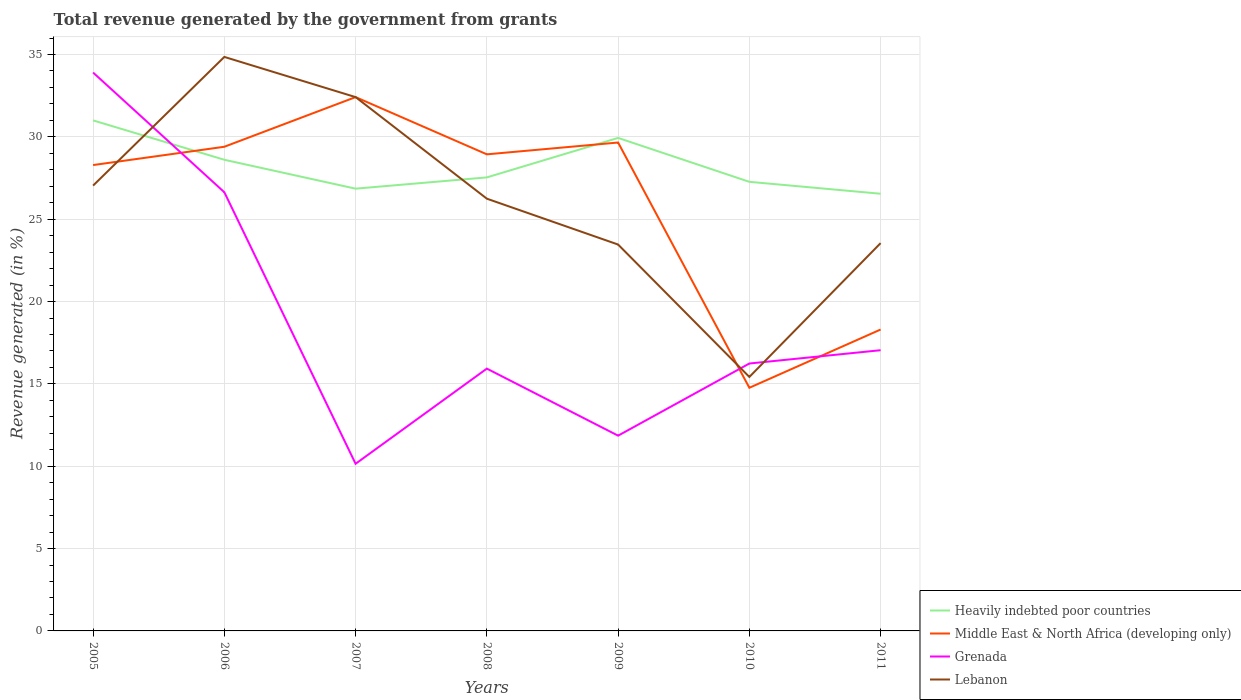How many different coloured lines are there?
Give a very brief answer. 4. Does the line corresponding to Heavily indebted poor countries intersect with the line corresponding to Grenada?
Provide a succinct answer. Yes. Is the number of lines equal to the number of legend labels?
Provide a succinct answer. Yes. Across all years, what is the maximum total revenue generated in Lebanon?
Your answer should be compact. 15.42. What is the total total revenue generated in Lebanon in the graph?
Offer a terse response. 2.7. What is the difference between the highest and the second highest total revenue generated in Lebanon?
Provide a short and direct response. 19.43. What is the difference between the highest and the lowest total revenue generated in Grenada?
Provide a short and direct response. 2. Is the total revenue generated in Grenada strictly greater than the total revenue generated in Middle East & North Africa (developing only) over the years?
Make the answer very short. No. How many lines are there?
Ensure brevity in your answer.  4. How many years are there in the graph?
Your answer should be compact. 7. What is the title of the graph?
Your response must be concise. Total revenue generated by the government from grants. Does "Solomon Islands" appear as one of the legend labels in the graph?
Your answer should be very brief. No. What is the label or title of the X-axis?
Make the answer very short. Years. What is the label or title of the Y-axis?
Provide a short and direct response. Revenue generated (in %). What is the Revenue generated (in %) of Heavily indebted poor countries in 2005?
Your answer should be compact. 31. What is the Revenue generated (in %) of Middle East & North Africa (developing only) in 2005?
Provide a short and direct response. 28.29. What is the Revenue generated (in %) of Grenada in 2005?
Your answer should be very brief. 33.9. What is the Revenue generated (in %) of Lebanon in 2005?
Your answer should be compact. 27.04. What is the Revenue generated (in %) of Heavily indebted poor countries in 2006?
Your answer should be very brief. 28.61. What is the Revenue generated (in %) of Middle East & North Africa (developing only) in 2006?
Make the answer very short. 29.4. What is the Revenue generated (in %) in Grenada in 2006?
Provide a succinct answer. 26.64. What is the Revenue generated (in %) in Lebanon in 2006?
Offer a very short reply. 34.85. What is the Revenue generated (in %) of Heavily indebted poor countries in 2007?
Your answer should be very brief. 26.85. What is the Revenue generated (in %) of Middle East & North Africa (developing only) in 2007?
Give a very brief answer. 32.41. What is the Revenue generated (in %) in Grenada in 2007?
Provide a succinct answer. 10.15. What is the Revenue generated (in %) of Lebanon in 2007?
Provide a short and direct response. 32.41. What is the Revenue generated (in %) in Heavily indebted poor countries in 2008?
Your response must be concise. 27.54. What is the Revenue generated (in %) in Middle East & North Africa (developing only) in 2008?
Give a very brief answer. 28.94. What is the Revenue generated (in %) of Grenada in 2008?
Provide a succinct answer. 15.93. What is the Revenue generated (in %) of Lebanon in 2008?
Offer a very short reply. 26.24. What is the Revenue generated (in %) of Heavily indebted poor countries in 2009?
Offer a terse response. 29.93. What is the Revenue generated (in %) in Middle East & North Africa (developing only) in 2009?
Ensure brevity in your answer.  29.65. What is the Revenue generated (in %) in Grenada in 2009?
Ensure brevity in your answer.  11.86. What is the Revenue generated (in %) in Lebanon in 2009?
Offer a terse response. 23.46. What is the Revenue generated (in %) of Heavily indebted poor countries in 2010?
Ensure brevity in your answer.  27.27. What is the Revenue generated (in %) in Middle East & North Africa (developing only) in 2010?
Provide a succinct answer. 14.76. What is the Revenue generated (in %) in Grenada in 2010?
Your answer should be very brief. 16.24. What is the Revenue generated (in %) of Lebanon in 2010?
Offer a very short reply. 15.42. What is the Revenue generated (in %) of Heavily indebted poor countries in 2011?
Your answer should be compact. 26.54. What is the Revenue generated (in %) in Middle East & North Africa (developing only) in 2011?
Give a very brief answer. 18.3. What is the Revenue generated (in %) of Grenada in 2011?
Give a very brief answer. 17.04. What is the Revenue generated (in %) of Lebanon in 2011?
Keep it short and to the point. 23.55. Across all years, what is the maximum Revenue generated (in %) of Heavily indebted poor countries?
Offer a terse response. 31. Across all years, what is the maximum Revenue generated (in %) of Middle East & North Africa (developing only)?
Your response must be concise. 32.41. Across all years, what is the maximum Revenue generated (in %) of Grenada?
Provide a short and direct response. 33.9. Across all years, what is the maximum Revenue generated (in %) in Lebanon?
Provide a short and direct response. 34.85. Across all years, what is the minimum Revenue generated (in %) in Heavily indebted poor countries?
Offer a terse response. 26.54. Across all years, what is the minimum Revenue generated (in %) of Middle East & North Africa (developing only)?
Provide a succinct answer. 14.76. Across all years, what is the minimum Revenue generated (in %) in Grenada?
Offer a terse response. 10.15. Across all years, what is the minimum Revenue generated (in %) of Lebanon?
Offer a terse response. 15.42. What is the total Revenue generated (in %) of Heavily indebted poor countries in the graph?
Ensure brevity in your answer.  197.75. What is the total Revenue generated (in %) of Middle East & North Africa (developing only) in the graph?
Your response must be concise. 181.75. What is the total Revenue generated (in %) of Grenada in the graph?
Provide a short and direct response. 131.75. What is the total Revenue generated (in %) of Lebanon in the graph?
Your answer should be very brief. 182.98. What is the difference between the Revenue generated (in %) in Heavily indebted poor countries in 2005 and that in 2006?
Ensure brevity in your answer.  2.39. What is the difference between the Revenue generated (in %) of Middle East & North Africa (developing only) in 2005 and that in 2006?
Your response must be concise. -1.11. What is the difference between the Revenue generated (in %) of Grenada in 2005 and that in 2006?
Provide a succinct answer. 7.27. What is the difference between the Revenue generated (in %) of Lebanon in 2005 and that in 2006?
Your answer should be very brief. -7.81. What is the difference between the Revenue generated (in %) in Heavily indebted poor countries in 2005 and that in 2007?
Your response must be concise. 4.15. What is the difference between the Revenue generated (in %) of Middle East & North Africa (developing only) in 2005 and that in 2007?
Your response must be concise. -4.13. What is the difference between the Revenue generated (in %) in Grenada in 2005 and that in 2007?
Give a very brief answer. 23.75. What is the difference between the Revenue generated (in %) in Lebanon in 2005 and that in 2007?
Ensure brevity in your answer.  -5.37. What is the difference between the Revenue generated (in %) in Heavily indebted poor countries in 2005 and that in 2008?
Offer a very short reply. 3.46. What is the difference between the Revenue generated (in %) in Middle East & North Africa (developing only) in 2005 and that in 2008?
Your response must be concise. -0.65. What is the difference between the Revenue generated (in %) in Grenada in 2005 and that in 2008?
Keep it short and to the point. 17.98. What is the difference between the Revenue generated (in %) in Lebanon in 2005 and that in 2008?
Offer a very short reply. 0.79. What is the difference between the Revenue generated (in %) of Heavily indebted poor countries in 2005 and that in 2009?
Provide a succinct answer. 1.06. What is the difference between the Revenue generated (in %) of Middle East & North Africa (developing only) in 2005 and that in 2009?
Keep it short and to the point. -1.37. What is the difference between the Revenue generated (in %) of Grenada in 2005 and that in 2009?
Ensure brevity in your answer.  22.05. What is the difference between the Revenue generated (in %) in Lebanon in 2005 and that in 2009?
Your answer should be very brief. 3.58. What is the difference between the Revenue generated (in %) in Heavily indebted poor countries in 2005 and that in 2010?
Make the answer very short. 3.73. What is the difference between the Revenue generated (in %) in Middle East & North Africa (developing only) in 2005 and that in 2010?
Your answer should be very brief. 13.52. What is the difference between the Revenue generated (in %) in Grenada in 2005 and that in 2010?
Keep it short and to the point. 17.67. What is the difference between the Revenue generated (in %) in Lebanon in 2005 and that in 2010?
Provide a short and direct response. 11.62. What is the difference between the Revenue generated (in %) of Heavily indebted poor countries in 2005 and that in 2011?
Ensure brevity in your answer.  4.45. What is the difference between the Revenue generated (in %) in Middle East & North Africa (developing only) in 2005 and that in 2011?
Provide a succinct answer. 9.99. What is the difference between the Revenue generated (in %) in Grenada in 2005 and that in 2011?
Your answer should be compact. 16.86. What is the difference between the Revenue generated (in %) in Lebanon in 2005 and that in 2011?
Give a very brief answer. 3.49. What is the difference between the Revenue generated (in %) in Heavily indebted poor countries in 2006 and that in 2007?
Keep it short and to the point. 1.75. What is the difference between the Revenue generated (in %) of Middle East & North Africa (developing only) in 2006 and that in 2007?
Your answer should be very brief. -3.01. What is the difference between the Revenue generated (in %) of Grenada in 2006 and that in 2007?
Your answer should be very brief. 16.49. What is the difference between the Revenue generated (in %) in Lebanon in 2006 and that in 2007?
Ensure brevity in your answer.  2.44. What is the difference between the Revenue generated (in %) in Heavily indebted poor countries in 2006 and that in 2008?
Offer a very short reply. 1.07. What is the difference between the Revenue generated (in %) of Middle East & North Africa (developing only) in 2006 and that in 2008?
Provide a succinct answer. 0.46. What is the difference between the Revenue generated (in %) in Grenada in 2006 and that in 2008?
Provide a succinct answer. 10.71. What is the difference between the Revenue generated (in %) of Lebanon in 2006 and that in 2008?
Your answer should be very brief. 8.61. What is the difference between the Revenue generated (in %) in Heavily indebted poor countries in 2006 and that in 2009?
Your answer should be very brief. -1.33. What is the difference between the Revenue generated (in %) of Middle East & North Africa (developing only) in 2006 and that in 2009?
Make the answer very short. -0.26. What is the difference between the Revenue generated (in %) of Grenada in 2006 and that in 2009?
Provide a succinct answer. 14.78. What is the difference between the Revenue generated (in %) in Lebanon in 2006 and that in 2009?
Your answer should be compact. 11.39. What is the difference between the Revenue generated (in %) in Heavily indebted poor countries in 2006 and that in 2010?
Offer a terse response. 1.34. What is the difference between the Revenue generated (in %) in Middle East & North Africa (developing only) in 2006 and that in 2010?
Your response must be concise. 14.63. What is the difference between the Revenue generated (in %) in Grenada in 2006 and that in 2010?
Your answer should be compact. 10.4. What is the difference between the Revenue generated (in %) of Lebanon in 2006 and that in 2010?
Offer a terse response. 19.43. What is the difference between the Revenue generated (in %) of Heavily indebted poor countries in 2006 and that in 2011?
Ensure brevity in your answer.  2.06. What is the difference between the Revenue generated (in %) in Middle East & North Africa (developing only) in 2006 and that in 2011?
Give a very brief answer. 11.1. What is the difference between the Revenue generated (in %) in Grenada in 2006 and that in 2011?
Your answer should be very brief. 9.59. What is the difference between the Revenue generated (in %) of Lebanon in 2006 and that in 2011?
Offer a terse response. 11.31. What is the difference between the Revenue generated (in %) in Heavily indebted poor countries in 2007 and that in 2008?
Offer a terse response. -0.68. What is the difference between the Revenue generated (in %) of Middle East & North Africa (developing only) in 2007 and that in 2008?
Provide a short and direct response. 3.47. What is the difference between the Revenue generated (in %) in Grenada in 2007 and that in 2008?
Ensure brevity in your answer.  -5.78. What is the difference between the Revenue generated (in %) of Lebanon in 2007 and that in 2008?
Provide a short and direct response. 6.17. What is the difference between the Revenue generated (in %) of Heavily indebted poor countries in 2007 and that in 2009?
Provide a succinct answer. -3.08. What is the difference between the Revenue generated (in %) of Middle East & North Africa (developing only) in 2007 and that in 2009?
Make the answer very short. 2.76. What is the difference between the Revenue generated (in %) in Grenada in 2007 and that in 2009?
Ensure brevity in your answer.  -1.71. What is the difference between the Revenue generated (in %) in Lebanon in 2007 and that in 2009?
Give a very brief answer. 8.95. What is the difference between the Revenue generated (in %) in Heavily indebted poor countries in 2007 and that in 2010?
Give a very brief answer. -0.42. What is the difference between the Revenue generated (in %) of Middle East & North Africa (developing only) in 2007 and that in 2010?
Provide a succinct answer. 17.65. What is the difference between the Revenue generated (in %) in Grenada in 2007 and that in 2010?
Make the answer very short. -6.09. What is the difference between the Revenue generated (in %) in Lebanon in 2007 and that in 2010?
Your answer should be compact. 16.99. What is the difference between the Revenue generated (in %) of Heavily indebted poor countries in 2007 and that in 2011?
Keep it short and to the point. 0.31. What is the difference between the Revenue generated (in %) of Middle East & North Africa (developing only) in 2007 and that in 2011?
Offer a terse response. 14.11. What is the difference between the Revenue generated (in %) of Grenada in 2007 and that in 2011?
Give a very brief answer. -6.89. What is the difference between the Revenue generated (in %) in Lebanon in 2007 and that in 2011?
Provide a succinct answer. 8.87. What is the difference between the Revenue generated (in %) of Heavily indebted poor countries in 2008 and that in 2009?
Keep it short and to the point. -2.4. What is the difference between the Revenue generated (in %) of Middle East & North Africa (developing only) in 2008 and that in 2009?
Make the answer very short. -0.72. What is the difference between the Revenue generated (in %) of Grenada in 2008 and that in 2009?
Your answer should be compact. 4.07. What is the difference between the Revenue generated (in %) in Lebanon in 2008 and that in 2009?
Keep it short and to the point. 2.78. What is the difference between the Revenue generated (in %) in Heavily indebted poor countries in 2008 and that in 2010?
Provide a succinct answer. 0.27. What is the difference between the Revenue generated (in %) in Middle East & North Africa (developing only) in 2008 and that in 2010?
Offer a terse response. 14.17. What is the difference between the Revenue generated (in %) in Grenada in 2008 and that in 2010?
Provide a succinct answer. -0.31. What is the difference between the Revenue generated (in %) of Lebanon in 2008 and that in 2010?
Provide a short and direct response. 10.82. What is the difference between the Revenue generated (in %) in Heavily indebted poor countries in 2008 and that in 2011?
Make the answer very short. 0.99. What is the difference between the Revenue generated (in %) of Middle East & North Africa (developing only) in 2008 and that in 2011?
Your answer should be compact. 10.64. What is the difference between the Revenue generated (in %) of Grenada in 2008 and that in 2011?
Offer a very short reply. -1.12. What is the difference between the Revenue generated (in %) of Lebanon in 2008 and that in 2011?
Your answer should be very brief. 2.7. What is the difference between the Revenue generated (in %) in Heavily indebted poor countries in 2009 and that in 2010?
Your answer should be compact. 2.67. What is the difference between the Revenue generated (in %) of Middle East & North Africa (developing only) in 2009 and that in 2010?
Offer a very short reply. 14.89. What is the difference between the Revenue generated (in %) of Grenada in 2009 and that in 2010?
Your response must be concise. -4.38. What is the difference between the Revenue generated (in %) in Lebanon in 2009 and that in 2010?
Offer a terse response. 8.04. What is the difference between the Revenue generated (in %) in Heavily indebted poor countries in 2009 and that in 2011?
Provide a short and direct response. 3.39. What is the difference between the Revenue generated (in %) of Middle East & North Africa (developing only) in 2009 and that in 2011?
Your answer should be compact. 11.35. What is the difference between the Revenue generated (in %) in Grenada in 2009 and that in 2011?
Keep it short and to the point. -5.19. What is the difference between the Revenue generated (in %) in Lebanon in 2009 and that in 2011?
Give a very brief answer. -0.09. What is the difference between the Revenue generated (in %) of Heavily indebted poor countries in 2010 and that in 2011?
Your response must be concise. 0.72. What is the difference between the Revenue generated (in %) of Middle East & North Africa (developing only) in 2010 and that in 2011?
Your response must be concise. -3.54. What is the difference between the Revenue generated (in %) in Grenada in 2010 and that in 2011?
Ensure brevity in your answer.  -0.81. What is the difference between the Revenue generated (in %) of Lebanon in 2010 and that in 2011?
Make the answer very short. -8.13. What is the difference between the Revenue generated (in %) of Heavily indebted poor countries in 2005 and the Revenue generated (in %) of Middle East & North Africa (developing only) in 2006?
Keep it short and to the point. 1.6. What is the difference between the Revenue generated (in %) in Heavily indebted poor countries in 2005 and the Revenue generated (in %) in Grenada in 2006?
Give a very brief answer. 4.36. What is the difference between the Revenue generated (in %) of Heavily indebted poor countries in 2005 and the Revenue generated (in %) of Lebanon in 2006?
Make the answer very short. -3.85. What is the difference between the Revenue generated (in %) of Middle East & North Africa (developing only) in 2005 and the Revenue generated (in %) of Grenada in 2006?
Provide a succinct answer. 1.65. What is the difference between the Revenue generated (in %) in Middle East & North Africa (developing only) in 2005 and the Revenue generated (in %) in Lebanon in 2006?
Provide a succinct answer. -6.57. What is the difference between the Revenue generated (in %) in Grenada in 2005 and the Revenue generated (in %) in Lebanon in 2006?
Offer a terse response. -0.95. What is the difference between the Revenue generated (in %) of Heavily indebted poor countries in 2005 and the Revenue generated (in %) of Middle East & North Africa (developing only) in 2007?
Provide a short and direct response. -1.41. What is the difference between the Revenue generated (in %) in Heavily indebted poor countries in 2005 and the Revenue generated (in %) in Grenada in 2007?
Provide a succinct answer. 20.85. What is the difference between the Revenue generated (in %) in Heavily indebted poor countries in 2005 and the Revenue generated (in %) in Lebanon in 2007?
Offer a terse response. -1.41. What is the difference between the Revenue generated (in %) of Middle East & North Africa (developing only) in 2005 and the Revenue generated (in %) of Grenada in 2007?
Offer a very short reply. 18.14. What is the difference between the Revenue generated (in %) of Middle East & North Africa (developing only) in 2005 and the Revenue generated (in %) of Lebanon in 2007?
Provide a succinct answer. -4.13. What is the difference between the Revenue generated (in %) of Grenada in 2005 and the Revenue generated (in %) of Lebanon in 2007?
Offer a very short reply. 1.49. What is the difference between the Revenue generated (in %) in Heavily indebted poor countries in 2005 and the Revenue generated (in %) in Middle East & North Africa (developing only) in 2008?
Offer a very short reply. 2.06. What is the difference between the Revenue generated (in %) of Heavily indebted poor countries in 2005 and the Revenue generated (in %) of Grenada in 2008?
Provide a succinct answer. 15.07. What is the difference between the Revenue generated (in %) in Heavily indebted poor countries in 2005 and the Revenue generated (in %) in Lebanon in 2008?
Your answer should be compact. 4.75. What is the difference between the Revenue generated (in %) of Middle East & North Africa (developing only) in 2005 and the Revenue generated (in %) of Grenada in 2008?
Your response must be concise. 12.36. What is the difference between the Revenue generated (in %) of Middle East & North Africa (developing only) in 2005 and the Revenue generated (in %) of Lebanon in 2008?
Your answer should be compact. 2.04. What is the difference between the Revenue generated (in %) of Grenada in 2005 and the Revenue generated (in %) of Lebanon in 2008?
Make the answer very short. 7.66. What is the difference between the Revenue generated (in %) in Heavily indebted poor countries in 2005 and the Revenue generated (in %) in Middle East & North Africa (developing only) in 2009?
Your answer should be very brief. 1.34. What is the difference between the Revenue generated (in %) in Heavily indebted poor countries in 2005 and the Revenue generated (in %) in Grenada in 2009?
Provide a short and direct response. 19.14. What is the difference between the Revenue generated (in %) in Heavily indebted poor countries in 2005 and the Revenue generated (in %) in Lebanon in 2009?
Provide a short and direct response. 7.54. What is the difference between the Revenue generated (in %) of Middle East & North Africa (developing only) in 2005 and the Revenue generated (in %) of Grenada in 2009?
Offer a terse response. 16.43. What is the difference between the Revenue generated (in %) in Middle East & North Africa (developing only) in 2005 and the Revenue generated (in %) in Lebanon in 2009?
Your answer should be very brief. 4.83. What is the difference between the Revenue generated (in %) of Grenada in 2005 and the Revenue generated (in %) of Lebanon in 2009?
Offer a terse response. 10.44. What is the difference between the Revenue generated (in %) in Heavily indebted poor countries in 2005 and the Revenue generated (in %) in Middle East & North Africa (developing only) in 2010?
Your answer should be compact. 16.23. What is the difference between the Revenue generated (in %) in Heavily indebted poor countries in 2005 and the Revenue generated (in %) in Grenada in 2010?
Provide a succinct answer. 14.76. What is the difference between the Revenue generated (in %) of Heavily indebted poor countries in 2005 and the Revenue generated (in %) of Lebanon in 2010?
Your response must be concise. 15.58. What is the difference between the Revenue generated (in %) in Middle East & North Africa (developing only) in 2005 and the Revenue generated (in %) in Grenada in 2010?
Provide a short and direct response. 12.05. What is the difference between the Revenue generated (in %) in Middle East & North Africa (developing only) in 2005 and the Revenue generated (in %) in Lebanon in 2010?
Ensure brevity in your answer.  12.87. What is the difference between the Revenue generated (in %) of Grenada in 2005 and the Revenue generated (in %) of Lebanon in 2010?
Make the answer very short. 18.48. What is the difference between the Revenue generated (in %) of Heavily indebted poor countries in 2005 and the Revenue generated (in %) of Middle East & North Africa (developing only) in 2011?
Offer a terse response. 12.7. What is the difference between the Revenue generated (in %) in Heavily indebted poor countries in 2005 and the Revenue generated (in %) in Grenada in 2011?
Give a very brief answer. 13.95. What is the difference between the Revenue generated (in %) of Heavily indebted poor countries in 2005 and the Revenue generated (in %) of Lebanon in 2011?
Ensure brevity in your answer.  7.45. What is the difference between the Revenue generated (in %) of Middle East & North Africa (developing only) in 2005 and the Revenue generated (in %) of Grenada in 2011?
Keep it short and to the point. 11.24. What is the difference between the Revenue generated (in %) of Middle East & North Africa (developing only) in 2005 and the Revenue generated (in %) of Lebanon in 2011?
Offer a very short reply. 4.74. What is the difference between the Revenue generated (in %) in Grenada in 2005 and the Revenue generated (in %) in Lebanon in 2011?
Your answer should be compact. 10.36. What is the difference between the Revenue generated (in %) in Heavily indebted poor countries in 2006 and the Revenue generated (in %) in Middle East & North Africa (developing only) in 2007?
Provide a succinct answer. -3.8. What is the difference between the Revenue generated (in %) in Heavily indebted poor countries in 2006 and the Revenue generated (in %) in Grenada in 2007?
Ensure brevity in your answer.  18.46. What is the difference between the Revenue generated (in %) of Heavily indebted poor countries in 2006 and the Revenue generated (in %) of Lebanon in 2007?
Give a very brief answer. -3.8. What is the difference between the Revenue generated (in %) of Middle East & North Africa (developing only) in 2006 and the Revenue generated (in %) of Grenada in 2007?
Your answer should be compact. 19.25. What is the difference between the Revenue generated (in %) of Middle East & North Africa (developing only) in 2006 and the Revenue generated (in %) of Lebanon in 2007?
Your response must be concise. -3.01. What is the difference between the Revenue generated (in %) in Grenada in 2006 and the Revenue generated (in %) in Lebanon in 2007?
Your answer should be compact. -5.78. What is the difference between the Revenue generated (in %) in Heavily indebted poor countries in 2006 and the Revenue generated (in %) in Middle East & North Africa (developing only) in 2008?
Ensure brevity in your answer.  -0.33. What is the difference between the Revenue generated (in %) in Heavily indebted poor countries in 2006 and the Revenue generated (in %) in Grenada in 2008?
Provide a succinct answer. 12.68. What is the difference between the Revenue generated (in %) in Heavily indebted poor countries in 2006 and the Revenue generated (in %) in Lebanon in 2008?
Make the answer very short. 2.36. What is the difference between the Revenue generated (in %) of Middle East & North Africa (developing only) in 2006 and the Revenue generated (in %) of Grenada in 2008?
Make the answer very short. 13.47. What is the difference between the Revenue generated (in %) of Middle East & North Africa (developing only) in 2006 and the Revenue generated (in %) of Lebanon in 2008?
Your answer should be compact. 3.15. What is the difference between the Revenue generated (in %) in Grenada in 2006 and the Revenue generated (in %) in Lebanon in 2008?
Your answer should be compact. 0.39. What is the difference between the Revenue generated (in %) of Heavily indebted poor countries in 2006 and the Revenue generated (in %) of Middle East & North Africa (developing only) in 2009?
Make the answer very short. -1.05. What is the difference between the Revenue generated (in %) of Heavily indebted poor countries in 2006 and the Revenue generated (in %) of Grenada in 2009?
Offer a very short reply. 16.75. What is the difference between the Revenue generated (in %) of Heavily indebted poor countries in 2006 and the Revenue generated (in %) of Lebanon in 2009?
Make the answer very short. 5.15. What is the difference between the Revenue generated (in %) in Middle East & North Africa (developing only) in 2006 and the Revenue generated (in %) in Grenada in 2009?
Give a very brief answer. 17.54. What is the difference between the Revenue generated (in %) of Middle East & North Africa (developing only) in 2006 and the Revenue generated (in %) of Lebanon in 2009?
Offer a terse response. 5.94. What is the difference between the Revenue generated (in %) in Grenada in 2006 and the Revenue generated (in %) in Lebanon in 2009?
Give a very brief answer. 3.17. What is the difference between the Revenue generated (in %) of Heavily indebted poor countries in 2006 and the Revenue generated (in %) of Middle East & North Africa (developing only) in 2010?
Make the answer very short. 13.84. What is the difference between the Revenue generated (in %) in Heavily indebted poor countries in 2006 and the Revenue generated (in %) in Grenada in 2010?
Keep it short and to the point. 12.37. What is the difference between the Revenue generated (in %) of Heavily indebted poor countries in 2006 and the Revenue generated (in %) of Lebanon in 2010?
Provide a succinct answer. 13.19. What is the difference between the Revenue generated (in %) in Middle East & North Africa (developing only) in 2006 and the Revenue generated (in %) in Grenada in 2010?
Keep it short and to the point. 13.16. What is the difference between the Revenue generated (in %) of Middle East & North Africa (developing only) in 2006 and the Revenue generated (in %) of Lebanon in 2010?
Ensure brevity in your answer.  13.98. What is the difference between the Revenue generated (in %) of Grenada in 2006 and the Revenue generated (in %) of Lebanon in 2010?
Provide a succinct answer. 11.21. What is the difference between the Revenue generated (in %) in Heavily indebted poor countries in 2006 and the Revenue generated (in %) in Middle East & North Africa (developing only) in 2011?
Your response must be concise. 10.31. What is the difference between the Revenue generated (in %) of Heavily indebted poor countries in 2006 and the Revenue generated (in %) of Grenada in 2011?
Keep it short and to the point. 11.56. What is the difference between the Revenue generated (in %) of Heavily indebted poor countries in 2006 and the Revenue generated (in %) of Lebanon in 2011?
Your answer should be compact. 5.06. What is the difference between the Revenue generated (in %) in Middle East & North Africa (developing only) in 2006 and the Revenue generated (in %) in Grenada in 2011?
Ensure brevity in your answer.  12.35. What is the difference between the Revenue generated (in %) in Middle East & North Africa (developing only) in 2006 and the Revenue generated (in %) in Lebanon in 2011?
Offer a very short reply. 5.85. What is the difference between the Revenue generated (in %) in Grenada in 2006 and the Revenue generated (in %) in Lebanon in 2011?
Your answer should be compact. 3.09. What is the difference between the Revenue generated (in %) of Heavily indebted poor countries in 2007 and the Revenue generated (in %) of Middle East & North Africa (developing only) in 2008?
Your answer should be compact. -2.08. What is the difference between the Revenue generated (in %) in Heavily indebted poor countries in 2007 and the Revenue generated (in %) in Grenada in 2008?
Your response must be concise. 10.93. What is the difference between the Revenue generated (in %) of Heavily indebted poor countries in 2007 and the Revenue generated (in %) of Lebanon in 2008?
Provide a succinct answer. 0.61. What is the difference between the Revenue generated (in %) in Middle East & North Africa (developing only) in 2007 and the Revenue generated (in %) in Grenada in 2008?
Ensure brevity in your answer.  16.49. What is the difference between the Revenue generated (in %) in Middle East & North Africa (developing only) in 2007 and the Revenue generated (in %) in Lebanon in 2008?
Give a very brief answer. 6.17. What is the difference between the Revenue generated (in %) in Grenada in 2007 and the Revenue generated (in %) in Lebanon in 2008?
Keep it short and to the point. -16.1. What is the difference between the Revenue generated (in %) in Heavily indebted poor countries in 2007 and the Revenue generated (in %) in Middle East & North Africa (developing only) in 2009?
Provide a short and direct response. -2.8. What is the difference between the Revenue generated (in %) of Heavily indebted poor countries in 2007 and the Revenue generated (in %) of Grenada in 2009?
Offer a very short reply. 15. What is the difference between the Revenue generated (in %) in Heavily indebted poor countries in 2007 and the Revenue generated (in %) in Lebanon in 2009?
Your answer should be compact. 3.39. What is the difference between the Revenue generated (in %) in Middle East & North Africa (developing only) in 2007 and the Revenue generated (in %) in Grenada in 2009?
Offer a very short reply. 20.56. What is the difference between the Revenue generated (in %) in Middle East & North Africa (developing only) in 2007 and the Revenue generated (in %) in Lebanon in 2009?
Provide a succinct answer. 8.95. What is the difference between the Revenue generated (in %) in Grenada in 2007 and the Revenue generated (in %) in Lebanon in 2009?
Offer a terse response. -13.31. What is the difference between the Revenue generated (in %) of Heavily indebted poor countries in 2007 and the Revenue generated (in %) of Middle East & North Africa (developing only) in 2010?
Your answer should be very brief. 12.09. What is the difference between the Revenue generated (in %) of Heavily indebted poor countries in 2007 and the Revenue generated (in %) of Grenada in 2010?
Offer a terse response. 10.62. What is the difference between the Revenue generated (in %) in Heavily indebted poor countries in 2007 and the Revenue generated (in %) in Lebanon in 2010?
Provide a short and direct response. 11.43. What is the difference between the Revenue generated (in %) in Middle East & North Africa (developing only) in 2007 and the Revenue generated (in %) in Grenada in 2010?
Offer a very short reply. 16.18. What is the difference between the Revenue generated (in %) in Middle East & North Africa (developing only) in 2007 and the Revenue generated (in %) in Lebanon in 2010?
Ensure brevity in your answer.  16.99. What is the difference between the Revenue generated (in %) in Grenada in 2007 and the Revenue generated (in %) in Lebanon in 2010?
Provide a succinct answer. -5.27. What is the difference between the Revenue generated (in %) of Heavily indebted poor countries in 2007 and the Revenue generated (in %) of Middle East & North Africa (developing only) in 2011?
Your response must be concise. 8.55. What is the difference between the Revenue generated (in %) of Heavily indebted poor countries in 2007 and the Revenue generated (in %) of Grenada in 2011?
Ensure brevity in your answer.  9.81. What is the difference between the Revenue generated (in %) in Heavily indebted poor countries in 2007 and the Revenue generated (in %) in Lebanon in 2011?
Make the answer very short. 3.31. What is the difference between the Revenue generated (in %) of Middle East & North Africa (developing only) in 2007 and the Revenue generated (in %) of Grenada in 2011?
Give a very brief answer. 15.37. What is the difference between the Revenue generated (in %) in Middle East & North Africa (developing only) in 2007 and the Revenue generated (in %) in Lebanon in 2011?
Your response must be concise. 8.87. What is the difference between the Revenue generated (in %) in Grenada in 2007 and the Revenue generated (in %) in Lebanon in 2011?
Your answer should be compact. -13.4. What is the difference between the Revenue generated (in %) of Heavily indebted poor countries in 2008 and the Revenue generated (in %) of Middle East & North Africa (developing only) in 2009?
Provide a succinct answer. -2.12. What is the difference between the Revenue generated (in %) in Heavily indebted poor countries in 2008 and the Revenue generated (in %) in Grenada in 2009?
Your answer should be compact. 15.68. What is the difference between the Revenue generated (in %) in Heavily indebted poor countries in 2008 and the Revenue generated (in %) in Lebanon in 2009?
Keep it short and to the point. 4.08. What is the difference between the Revenue generated (in %) of Middle East & North Africa (developing only) in 2008 and the Revenue generated (in %) of Grenada in 2009?
Your response must be concise. 17.08. What is the difference between the Revenue generated (in %) of Middle East & North Africa (developing only) in 2008 and the Revenue generated (in %) of Lebanon in 2009?
Make the answer very short. 5.48. What is the difference between the Revenue generated (in %) in Grenada in 2008 and the Revenue generated (in %) in Lebanon in 2009?
Ensure brevity in your answer.  -7.53. What is the difference between the Revenue generated (in %) in Heavily indebted poor countries in 2008 and the Revenue generated (in %) in Middle East & North Africa (developing only) in 2010?
Provide a succinct answer. 12.77. What is the difference between the Revenue generated (in %) in Heavily indebted poor countries in 2008 and the Revenue generated (in %) in Grenada in 2010?
Keep it short and to the point. 11.3. What is the difference between the Revenue generated (in %) of Heavily indebted poor countries in 2008 and the Revenue generated (in %) of Lebanon in 2010?
Offer a terse response. 12.12. What is the difference between the Revenue generated (in %) of Middle East & North Africa (developing only) in 2008 and the Revenue generated (in %) of Grenada in 2010?
Keep it short and to the point. 12.7. What is the difference between the Revenue generated (in %) of Middle East & North Africa (developing only) in 2008 and the Revenue generated (in %) of Lebanon in 2010?
Provide a short and direct response. 13.52. What is the difference between the Revenue generated (in %) in Grenada in 2008 and the Revenue generated (in %) in Lebanon in 2010?
Keep it short and to the point. 0.51. What is the difference between the Revenue generated (in %) in Heavily indebted poor countries in 2008 and the Revenue generated (in %) in Middle East & North Africa (developing only) in 2011?
Your response must be concise. 9.24. What is the difference between the Revenue generated (in %) of Heavily indebted poor countries in 2008 and the Revenue generated (in %) of Grenada in 2011?
Your answer should be very brief. 10.49. What is the difference between the Revenue generated (in %) of Heavily indebted poor countries in 2008 and the Revenue generated (in %) of Lebanon in 2011?
Provide a short and direct response. 3.99. What is the difference between the Revenue generated (in %) in Middle East & North Africa (developing only) in 2008 and the Revenue generated (in %) in Grenada in 2011?
Offer a terse response. 11.89. What is the difference between the Revenue generated (in %) in Middle East & North Africa (developing only) in 2008 and the Revenue generated (in %) in Lebanon in 2011?
Provide a succinct answer. 5.39. What is the difference between the Revenue generated (in %) in Grenada in 2008 and the Revenue generated (in %) in Lebanon in 2011?
Make the answer very short. -7.62. What is the difference between the Revenue generated (in %) of Heavily indebted poor countries in 2009 and the Revenue generated (in %) of Middle East & North Africa (developing only) in 2010?
Your answer should be compact. 15.17. What is the difference between the Revenue generated (in %) in Heavily indebted poor countries in 2009 and the Revenue generated (in %) in Grenada in 2010?
Offer a terse response. 13.7. What is the difference between the Revenue generated (in %) in Heavily indebted poor countries in 2009 and the Revenue generated (in %) in Lebanon in 2010?
Offer a terse response. 14.51. What is the difference between the Revenue generated (in %) in Middle East & North Africa (developing only) in 2009 and the Revenue generated (in %) in Grenada in 2010?
Make the answer very short. 13.42. What is the difference between the Revenue generated (in %) in Middle East & North Africa (developing only) in 2009 and the Revenue generated (in %) in Lebanon in 2010?
Your answer should be compact. 14.23. What is the difference between the Revenue generated (in %) in Grenada in 2009 and the Revenue generated (in %) in Lebanon in 2010?
Your response must be concise. -3.56. What is the difference between the Revenue generated (in %) in Heavily indebted poor countries in 2009 and the Revenue generated (in %) in Middle East & North Africa (developing only) in 2011?
Your response must be concise. 11.63. What is the difference between the Revenue generated (in %) in Heavily indebted poor countries in 2009 and the Revenue generated (in %) in Grenada in 2011?
Make the answer very short. 12.89. What is the difference between the Revenue generated (in %) in Heavily indebted poor countries in 2009 and the Revenue generated (in %) in Lebanon in 2011?
Your response must be concise. 6.39. What is the difference between the Revenue generated (in %) in Middle East & North Africa (developing only) in 2009 and the Revenue generated (in %) in Grenada in 2011?
Ensure brevity in your answer.  12.61. What is the difference between the Revenue generated (in %) of Middle East & North Africa (developing only) in 2009 and the Revenue generated (in %) of Lebanon in 2011?
Make the answer very short. 6.11. What is the difference between the Revenue generated (in %) in Grenada in 2009 and the Revenue generated (in %) in Lebanon in 2011?
Give a very brief answer. -11.69. What is the difference between the Revenue generated (in %) of Heavily indebted poor countries in 2010 and the Revenue generated (in %) of Middle East & North Africa (developing only) in 2011?
Your answer should be very brief. 8.97. What is the difference between the Revenue generated (in %) of Heavily indebted poor countries in 2010 and the Revenue generated (in %) of Grenada in 2011?
Provide a succinct answer. 10.22. What is the difference between the Revenue generated (in %) of Heavily indebted poor countries in 2010 and the Revenue generated (in %) of Lebanon in 2011?
Keep it short and to the point. 3.72. What is the difference between the Revenue generated (in %) in Middle East & North Africa (developing only) in 2010 and the Revenue generated (in %) in Grenada in 2011?
Your answer should be very brief. -2.28. What is the difference between the Revenue generated (in %) in Middle East & North Africa (developing only) in 2010 and the Revenue generated (in %) in Lebanon in 2011?
Provide a short and direct response. -8.78. What is the difference between the Revenue generated (in %) in Grenada in 2010 and the Revenue generated (in %) in Lebanon in 2011?
Provide a short and direct response. -7.31. What is the average Revenue generated (in %) in Heavily indebted poor countries per year?
Keep it short and to the point. 28.25. What is the average Revenue generated (in %) in Middle East & North Africa (developing only) per year?
Offer a terse response. 25.96. What is the average Revenue generated (in %) of Grenada per year?
Provide a short and direct response. 18.82. What is the average Revenue generated (in %) of Lebanon per year?
Give a very brief answer. 26.14. In the year 2005, what is the difference between the Revenue generated (in %) in Heavily indebted poor countries and Revenue generated (in %) in Middle East & North Africa (developing only)?
Provide a succinct answer. 2.71. In the year 2005, what is the difference between the Revenue generated (in %) of Heavily indebted poor countries and Revenue generated (in %) of Grenada?
Provide a short and direct response. -2.9. In the year 2005, what is the difference between the Revenue generated (in %) in Heavily indebted poor countries and Revenue generated (in %) in Lebanon?
Keep it short and to the point. 3.96. In the year 2005, what is the difference between the Revenue generated (in %) of Middle East & North Africa (developing only) and Revenue generated (in %) of Grenada?
Provide a short and direct response. -5.62. In the year 2005, what is the difference between the Revenue generated (in %) of Middle East & North Africa (developing only) and Revenue generated (in %) of Lebanon?
Your answer should be compact. 1.25. In the year 2005, what is the difference between the Revenue generated (in %) in Grenada and Revenue generated (in %) in Lebanon?
Offer a very short reply. 6.86. In the year 2006, what is the difference between the Revenue generated (in %) in Heavily indebted poor countries and Revenue generated (in %) in Middle East & North Africa (developing only)?
Give a very brief answer. -0.79. In the year 2006, what is the difference between the Revenue generated (in %) of Heavily indebted poor countries and Revenue generated (in %) of Grenada?
Offer a very short reply. 1.97. In the year 2006, what is the difference between the Revenue generated (in %) in Heavily indebted poor countries and Revenue generated (in %) in Lebanon?
Your response must be concise. -6.25. In the year 2006, what is the difference between the Revenue generated (in %) of Middle East & North Africa (developing only) and Revenue generated (in %) of Grenada?
Offer a terse response. 2.76. In the year 2006, what is the difference between the Revenue generated (in %) in Middle East & North Africa (developing only) and Revenue generated (in %) in Lebanon?
Offer a terse response. -5.45. In the year 2006, what is the difference between the Revenue generated (in %) of Grenada and Revenue generated (in %) of Lebanon?
Ensure brevity in your answer.  -8.22. In the year 2007, what is the difference between the Revenue generated (in %) of Heavily indebted poor countries and Revenue generated (in %) of Middle East & North Africa (developing only)?
Your answer should be very brief. -5.56. In the year 2007, what is the difference between the Revenue generated (in %) in Heavily indebted poor countries and Revenue generated (in %) in Grenada?
Make the answer very short. 16.7. In the year 2007, what is the difference between the Revenue generated (in %) of Heavily indebted poor countries and Revenue generated (in %) of Lebanon?
Ensure brevity in your answer.  -5.56. In the year 2007, what is the difference between the Revenue generated (in %) of Middle East & North Africa (developing only) and Revenue generated (in %) of Grenada?
Provide a succinct answer. 22.26. In the year 2007, what is the difference between the Revenue generated (in %) in Middle East & North Africa (developing only) and Revenue generated (in %) in Lebanon?
Your answer should be very brief. 0. In the year 2007, what is the difference between the Revenue generated (in %) of Grenada and Revenue generated (in %) of Lebanon?
Keep it short and to the point. -22.26. In the year 2008, what is the difference between the Revenue generated (in %) of Heavily indebted poor countries and Revenue generated (in %) of Middle East & North Africa (developing only)?
Offer a terse response. -1.4. In the year 2008, what is the difference between the Revenue generated (in %) in Heavily indebted poor countries and Revenue generated (in %) in Grenada?
Your response must be concise. 11.61. In the year 2008, what is the difference between the Revenue generated (in %) of Heavily indebted poor countries and Revenue generated (in %) of Lebanon?
Your answer should be very brief. 1.29. In the year 2008, what is the difference between the Revenue generated (in %) in Middle East & North Africa (developing only) and Revenue generated (in %) in Grenada?
Offer a terse response. 13.01. In the year 2008, what is the difference between the Revenue generated (in %) in Middle East & North Africa (developing only) and Revenue generated (in %) in Lebanon?
Ensure brevity in your answer.  2.69. In the year 2008, what is the difference between the Revenue generated (in %) in Grenada and Revenue generated (in %) in Lebanon?
Your response must be concise. -10.32. In the year 2009, what is the difference between the Revenue generated (in %) in Heavily indebted poor countries and Revenue generated (in %) in Middle East & North Africa (developing only)?
Keep it short and to the point. 0.28. In the year 2009, what is the difference between the Revenue generated (in %) in Heavily indebted poor countries and Revenue generated (in %) in Grenada?
Offer a very short reply. 18.08. In the year 2009, what is the difference between the Revenue generated (in %) in Heavily indebted poor countries and Revenue generated (in %) in Lebanon?
Your response must be concise. 6.47. In the year 2009, what is the difference between the Revenue generated (in %) in Middle East & North Africa (developing only) and Revenue generated (in %) in Grenada?
Offer a terse response. 17.8. In the year 2009, what is the difference between the Revenue generated (in %) of Middle East & North Africa (developing only) and Revenue generated (in %) of Lebanon?
Offer a terse response. 6.19. In the year 2009, what is the difference between the Revenue generated (in %) in Grenada and Revenue generated (in %) in Lebanon?
Offer a terse response. -11.6. In the year 2010, what is the difference between the Revenue generated (in %) of Heavily indebted poor countries and Revenue generated (in %) of Middle East & North Africa (developing only)?
Make the answer very short. 12.5. In the year 2010, what is the difference between the Revenue generated (in %) in Heavily indebted poor countries and Revenue generated (in %) in Grenada?
Your answer should be compact. 11.03. In the year 2010, what is the difference between the Revenue generated (in %) in Heavily indebted poor countries and Revenue generated (in %) in Lebanon?
Make the answer very short. 11.85. In the year 2010, what is the difference between the Revenue generated (in %) in Middle East & North Africa (developing only) and Revenue generated (in %) in Grenada?
Ensure brevity in your answer.  -1.47. In the year 2010, what is the difference between the Revenue generated (in %) of Middle East & North Africa (developing only) and Revenue generated (in %) of Lebanon?
Your answer should be compact. -0.66. In the year 2010, what is the difference between the Revenue generated (in %) in Grenada and Revenue generated (in %) in Lebanon?
Provide a succinct answer. 0.82. In the year 2011, what is the difference between the Revenue generated (in %) of Heavily indebted poor countries and Revenue generated (in %) of Middle East & North Africa (developing only)?
Keep it short and to the point. 8.24. In the year 2011, what is the difference between the Revenue generated (in %) in Heavily indebted poor countries and Revenue generated (in %) in Grenada?
Your answer should be compact. 9.5. In the year 2011, what is the difference between the Revenue generated (in %) of Heavily indebted poor countries and Revenue generated (in %) of Lebanon?
Give a very brief answer. 3. In the year 2011, what is the difference between the Revenue generated (in %) of Middle East & North Africa (developing only) and Revenue generated (in %) of Grenada?
Offer a very short reply. 1.26. In the year 2011, what is the difference between the Revenue generated (in %) of Middle East & North Africa (developing only) and Revenue generated (in %) of Lebanon?
Provide a succinct answer. -5.25. In the year 2011, what is the difference between the Revenue generated (in %) of Grenada and Revenue generated (in %) of Lebanon?
Your response must be concise. -6.5. What is the ratio of the Revenue generated (in %) of Heavily indebted poor countries in 2005 to that in 2006?
Provide a succinct answer. 1.08. What is the ratio of the Revenue generated (in %) of Middle East & North Africa (developing only) in 2005 to that in 2006?
Your response must be concise. 0.96. What is the ratio of the Revenue generated (in %) of Grenada in 2005 to that in 2006?
Offer a very short reply. 1.27. What is the ratio of the Revenue generated (in %) of Lebanon in 2005 to that in 2006?
Give a very brief answer. 0.78. What is the ratio of the Revenue generated (in %) in Heavily indebted poor countries in 2005 to that in 2007?
Ensure brevity in your answer.  1.15. What is the ratio of the Revenue generated (in %) of Middle East & North Africa (developing only) in 2005 to that in 2007?
Keep it short and to the point. 0.87. What is the ratio of the Revenue generated (in %) in Grenada in 2005 to that in 2007?
Keep it short and to the point. 3.34. What is the ratio of the Revenue generated (in %) of Lebanon in 2005 to that in 2007?
Make the answer very short. 0.83. What is the ratio of the Revenue generated (in %) of Heavily indebted poor countries in 2005 to that in 2008?
Your answer should be very brief. 1.13. What is the ratio of the Revenue generated (in %) in Middle East & North Africa (developing only) in 2005 to that in 2008?
Your response must be concise. 0.98. What is the ratio of the Revenue generated (in %) of Grenada in 2005 to that in 2008?
Ensure brevity in your answer.  2.13. What is the ratio of the Revenue generated (in %) of Lebanon in 2005 to that in 2008?
Ensure brevity in your answer.  1.03. What is the ratio of the Revenue generated (in %) in Heavily indebted poor countries in 2005 to that in 2009?
Your response must be concise. 1.04. What is the ratio of the Revenue generated (in %) of Middle East & North Africa (developing only) in 2005 to that in 2009?
Make the answer very short. 0.95. What is the ratio of the Revenue generated (in %) in Grenada in 2005 to that in 2009?
Make the answer very short. 2.86. What is the ratio of the Revenue generated (in %) of Lebanon in 2005 to that in 2009?
Keep it short and to the point. 1.15. What is the ratio of the Revenue generated (in %) of Heavily indebted poor countries in 2005 to that in 2010?
Provide a succinct answer. 1.14. What is the ratio of the Revenue generated (in %) of Middle East & North Africa (developing only) in 2005 to that in 2010?
Keep it short and to the point. 1.92. What is the ratio of the Revenue generated (in %) of Grenada in 2005 to that in 2010?
Provide a succinct answer. 2.09. What is the ratio of the Revenue generated (in %) of Lebanon in 2005 to that in 2010?
Give a very brief answer. 1.75. What is the ratio of the Revenue generated (in %) in Heavily indebted poor countries in 2005 to that in 2011?
Give a very brief answer. 1.17. What is the ratio of the Revenue generated (in %) of Middle East & North Africa (developing only) in 2005 to that in 2011?
Give a very brief answer. 1.55. What is the ratio of the Revenue generated (in %) in Grenada in 2005 to that in 2011?
Your answer should be very brief. 1.99. What is the ratio of the Revenue generated (in %) of Lebanon in 2005 to that in 2011?
Ensure brevity in your answer.  1.15. What is the ratio of the Revenue generated (in %) in Heavily indebted poor countries in 2006 to that in 2007?
Ensure brevity in your answer.  1.07. What is the ratio of the Revenue generated (in %) in Middle East & North Africa (developing only) in 2006 to that in 2007?
Offer a terse response. 0.91. What is the ratio of the Revenue generated (in %) in Grenada in 2006 to that in 2007?
Your answer should be very brief. 2.62. What is the ratio of the Revenue generated (in %) of Lebanon in 2006 to that in 2007?
Give a very brief answer. 1.08. What is the ratio of the Revenue generated (in %) of Heavily indebted poor countries in 2006 to that in 2008?
Give a very brief answer. 1.04. What is the ratio of the Revenue generated (in %) in Middle East & North Africa (developing only) in 2006 to that in 2008?
Give a very brief answer. 1.02. What is the ratio of the Revenue generated (in %) in Grenada in 2006 to that in 2008?
Offer a terse response. 1.67. What is the ratio of the Revenue generated (in %) in Lebanon in 2006 to that in 2008?
Your response must be concise. 1.33. What is the ratio of the Revenue generated (in %) of Heavily indebted poor countries in 2006 to that in 2009?
Keep it short and to the point. 0.96. What is the ratio of the Revenue generated (in %) of Middle East & North Africa (developing only) in 2006 to that in 2009?
Provide a succinct answer. 0.99. What is the ratio of the Revenue generated (in %) of Grenada in 2006 to that in 2009?
Offer a terse response. 2.25. What is the ratio of the Revenue generated (in %) of Lebanon in 2006 to that in 2009?
Give a very brief answer. 1.49. What is the ratio of the Revenue generated (in %) in Heavily indebted poor countries in 2006 to that in 2010?
Offer a terse response. 1.05. What is the ratio of the Revenue generated (in %) in Middle East & North Africa (developing only) in 2006 to that in 2010?
Ensure brevity in your answer.  1.99. What is the ratio of the Revenue generated (in %) of Grenada in 2006 to that in 2010?
Ensure brevity in your answer.  1.64. What is the ratio of the Revenue generated (in %) in Lebanon in 2006 to that in 2010?
Keep it short and to the point. 2.26. What is the ratio of the Revenue generated (in %) in Heavily indebted poor countries in 2006 to that in 2011?
Provide a succinct answer. 1.08. What is the ratio of the Revenue generated (in %) of Middle East & North Africa (developing only) in 2006 to that in 2011?
Your answer should be very brief. 1.61. What is the ratio of the Revenue generated (in %) of Grenada in 2006 to that in 2011?
Keep it short and to the point. 1.56. What is the ratio of the Revenue generated (in %) in Lebanon in 2006 to that in 2011?
Offer a terse response. 1.48. What is the ratio of the Revenue generated (in %) of Heavily indebted poor countries in 2007 to that in 2008?
Offer a terse response. 0.98. What is the ratio of the Revenue generated (in %) of Middle East & North Africa (developing only) in 2007 to that in 2008?
Your answer should be very brief. 1.12. What is the ratio of the Revenue generated (in %) of Grenada in 2007 to that in 2008?
Your answer should be very brief. 0.64. What is the ratio of the Revenue generated (in %) of Lebanon in 2007 to that in 2008?
Your answer should be compact. 1.24. What is the ratio of the Revenue generated (in %) of Heavily indebted poor countries in 2007 to that in 2009?
Make the answer very short. 0.9. What is the ratio of the Revenue generated (in %) of Middle East & North Africa (developing only) in 2007 to that in 2009?
Give a very brief answer. 1.09. What is the ratio of the Revenue generated (in %) of Grenada in 2007 to that in 2009?
Provide a short and direct response. 0.86. What is the ratio of the Revenue generated (in %) of Lebanon in 2007 to that in 2009?
Provide a succinct answer. 1.38. What is the ratio of the Revenue generated (in %) in Middle East & North Africa (developing only) in 2007 to that in 2010?
Your response must be concise. 2.2. What is the ratio of the Revenue generated (in %) in Grenada in 2007 to that in 2010?
Ensure brevity in your answer.  0.63. What is the ratio of the Revenue generated (in %) of Lebanon in 2007 to that in 2010?
Keep it short and to the point. 2.1. What is the ratio of the Revenue generated (in %) in Heavily indebted poor countries in 2007 to that in 2011?
Your answer should be compact. 1.01. What is the ratio of the Revenue generated (in %) of Middle East & North Africa (developing only) in 2007 to that in 2011?
Provide a succinct answer. 1.77. What is the ratio of the Revenue generated (in %) of Grenada in 2007 to that in 2011?
Offer a terse response. 0.6. What is the ratio of the Revenue generated (in %) of Lebanon in 2007 to that in 2011?
Offer a very short reply. 1.38. What is the ratio of the Revenue generated (in %) of Heavily indebted poor countries in 2008 to that in 2009?
Your answer should be compact. 0.92. What is the ratio of the Revenue generated (in %) in Middle East & North Africa (developing only) in 2008 to that in 2009?
Offer a very short reply. 0.98. What is the ratio of the Revenue generated (in %) of Grenada in 2008 to that in 2009?
Ensure brevity in your answer.  1.34. What is the ratio of the Revenue generated (in %) in Lebanon in 2008 to that in 2009?
Your answer should be compact. 1.12. What is the ratio of the Revenue generated (in %) in Heavily indebted poor countries in 2008 to that in 2010?
Provide a succinct answer. 1.01. What is the ratio of the Revenue generated (in %) of Middle East & North Africa (developing only) in 2008 to that in 2010?
Make the answer very short. 1.96. What is the ratio of the Revenue generated (in %) of Grenada in 2008 to that in 2010?
Provide a short and direct response. 0.98. What is the ratio of the Revenue generated (in %) of Lebanon in 2008 to that in 2010?
Ensure brevity in your answer.  1.7. What is the ratio of the Revenue generated (in %) in Heavily indebted poor countries in 2008 to that in 2011?
Your response must be concise. 1.04. What is the ratio of the Revenue generated (in %) in Middle East & North Africa (developing only) in 2008 to that in 2011?
Your answer should be compact. 1.58. What is the ratio of the Revenue generated (in %) of Grenada in 2008 to that in 2011?
Your response must be concise. 0.93. What is the ratio of the Revenue generated (in %) in Lebanon in 2008 to that in 2011?
Provide a short and direct response. 1.11. What is the ratio of the Revenue generated (in %) in Heavily indebted poor countries in 2009 to that in 2010?
Make the answer very short. 1.1. What is the ratio of the Revenue generated (in %) of Middle East & North Africa (developing only) in 2009 to that in 2010?
Make the answer very short. 2.01. What is the ratio of the Revenue generated (in %) in Grenada in 2009 to that in 2010?
Provide a succinct answer. 0.73. What is the ratio of the Revenue generated (in %) in Lebanon in 2009 to that in 2010?
Offer a very short reply. 1.52. What is the ratio of the Revenue generated (in %) of Heavily indebted poor countries in 2009 to that in 2011?
Provide a short and direct response. 1.13. What is the ratio of the Revenue generated (in %) in Middle East & North Africa (developing only) in 2009 to that in 2011?
Provide a short and direct response. 1.62. What is the ratio of the Revenue generated (in %) in Grenada in 2009 to that in 2011?
Keep it short and to the point. 0.7. What is the ratio of the Revenue generated (in %) in Heavily indebted poor countries in 2010 to that in 2011?
Give a very brief answer. 1.03. What is the ratio of the Revenue generated (in %) in Middle East & North Africa (developing only) in 2010 to that in 2011?
Provide a short and direct response. 0.81. What is the ratio of the Revenue generated (in %) of Grenada in 2010 to that in 2011?
Your answer should be compact. 0.95. What is the ratio of the Revenue generated (in %) of Lebanon in 2010 to that in 2011?
Your response must be concise. 0.65. What is the difference between the highest and the second highest Revenue generated (in %) of Heavily indebted poor countries?
Make the answer very short. 1.06. What is the difference between the highest and the second highest Revenue generated (in %) of Middle East & North Africa (developing only)?
Offer a terse response. 2.76. What is the difference between the highest and the second highest Revenue generated (in %) in Grenada?
Your answer should be very brief. 7.27. What is the difference between the highest and the second highest Revenue generated (in %) in Lebanon?
Provide a short and direct response. 2.44. What is the difference between the highest and the lowest Revenue generated (in %) of Heavily indebted poor countries?
Your answer should be very brief. 4.45. What is the difference between the highest and the lowest Revenue generated (in %) in Middle East & North Africa (developing only)?
Your answer should be compact. 17.65. What is the difference between the highest and the lowest Revenue generated (in %) in Grenada?
Give a very brief answer. 23.75. What is the difference between the highest and the lowest Revenue generated (in %) in Lebanon?
Keep it short and to the point. 19.43. 